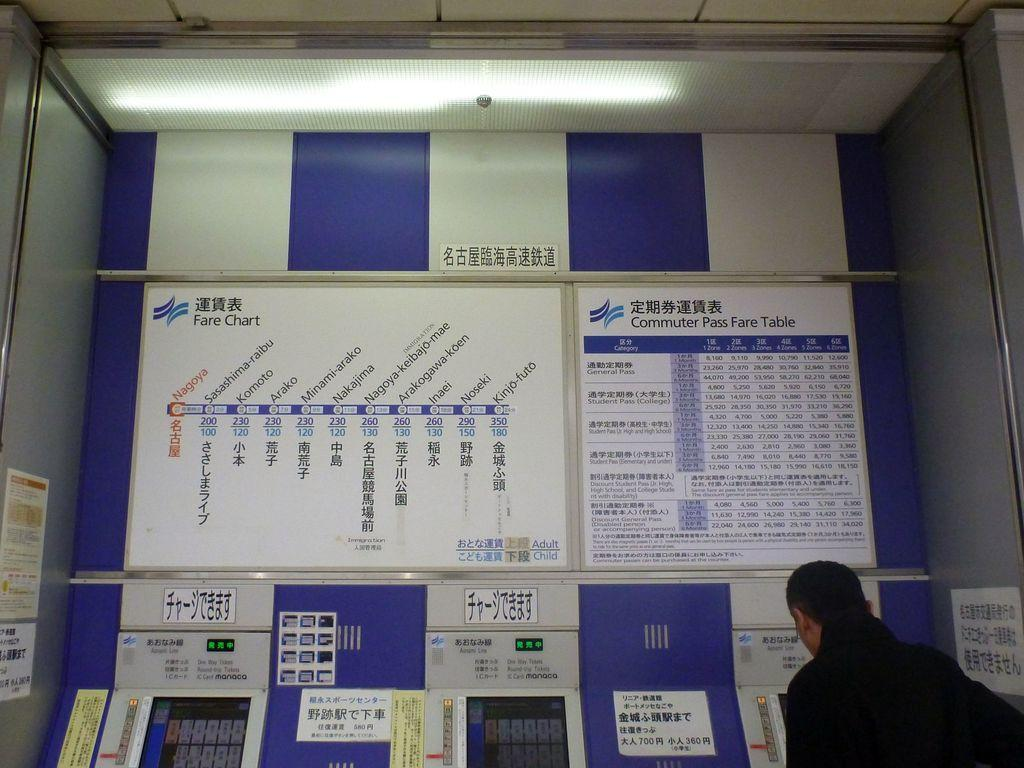<image>
Create a compact narrative representing the image presented. A mann looks at a kiosk below a sign for commuter pass fares. 